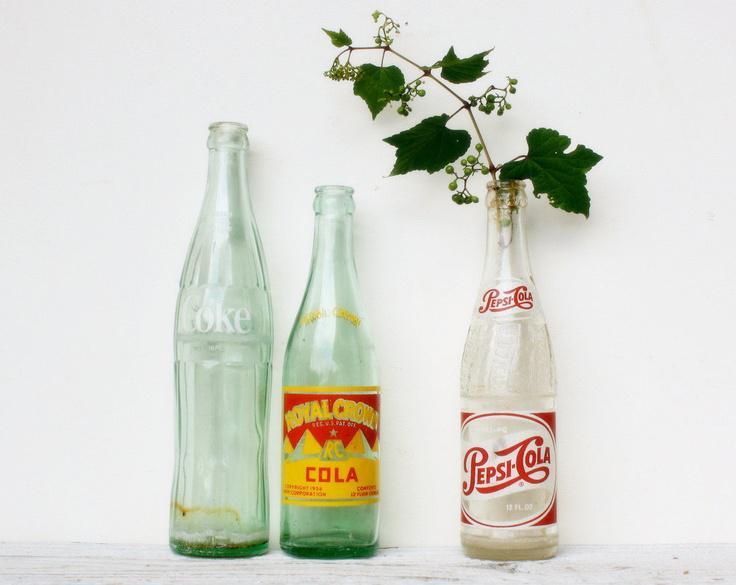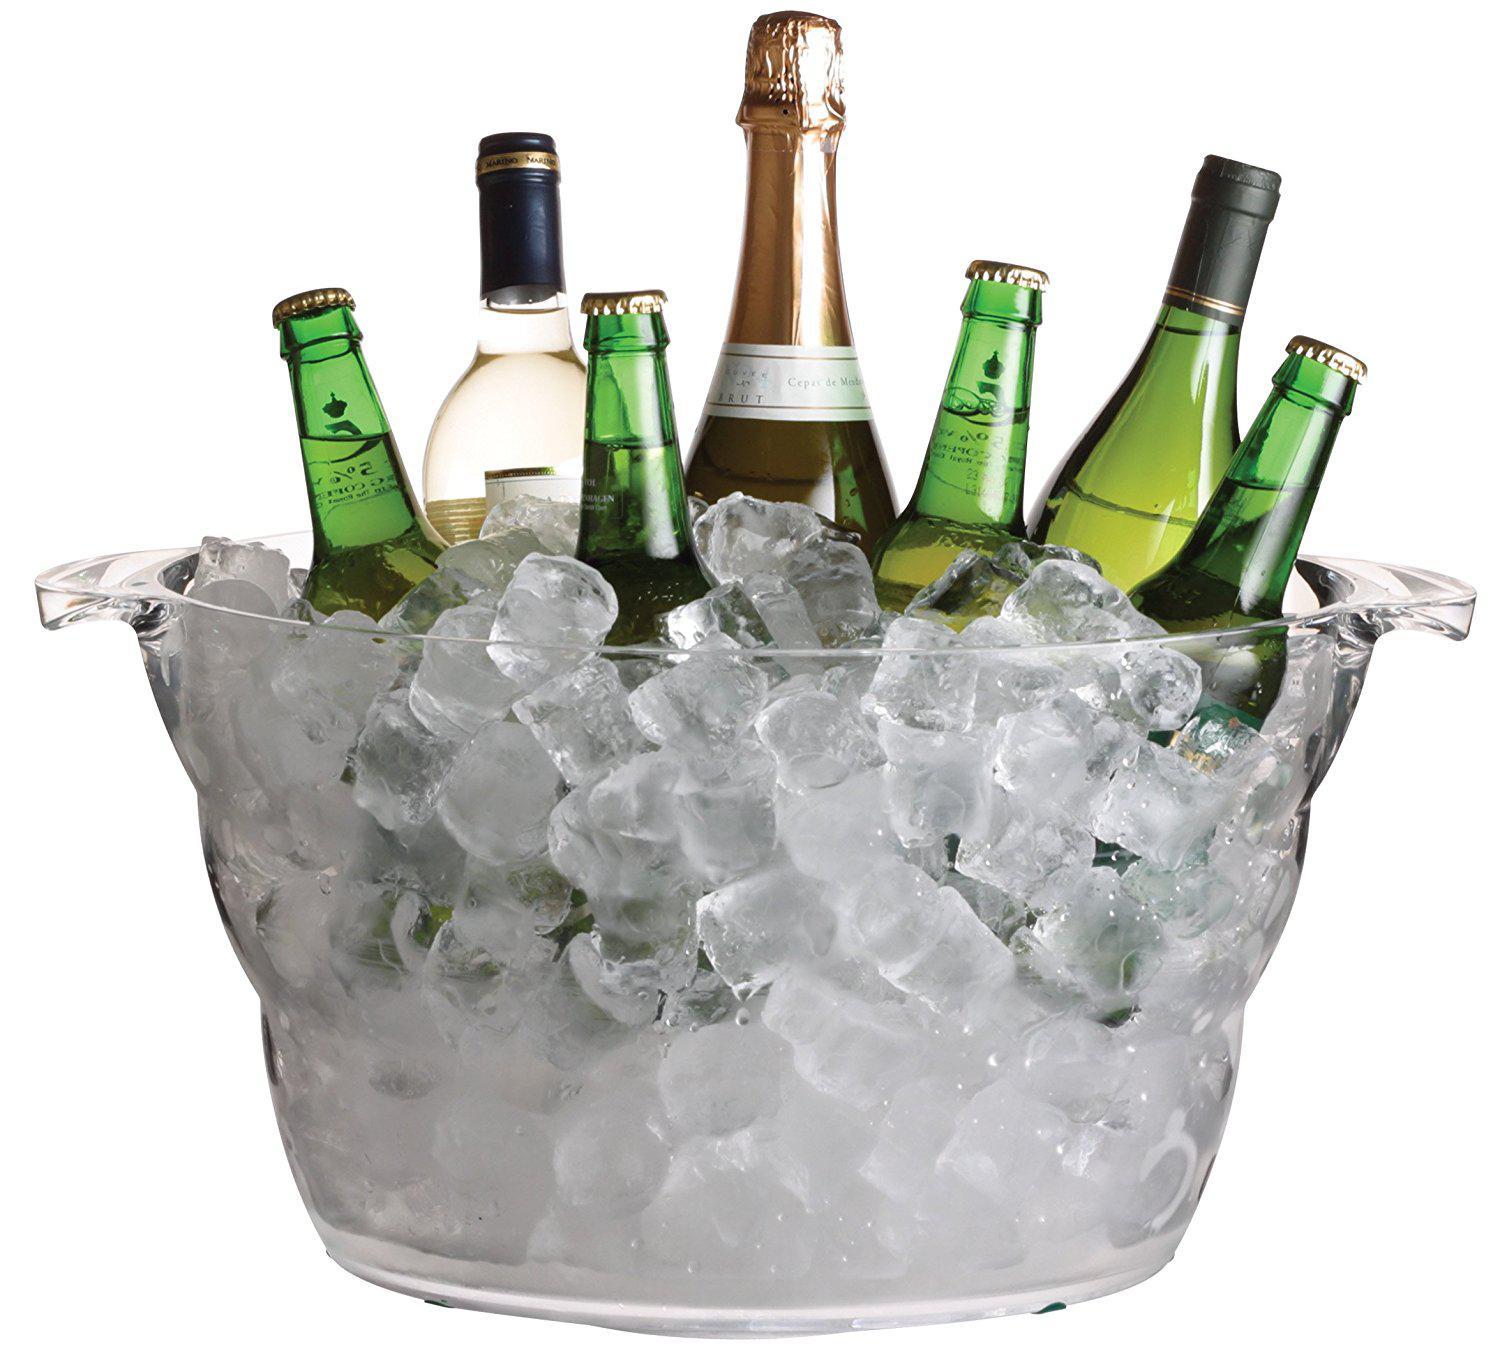The first image is the image on the left, the second image is the image on the right. For the images shown, is this caption "One image shows several bottles sticking out of a bucket." true? Answer yes or no. Yes. The first image is the image on the left, the second image is the image on the right. Analyze the images presented: Is the assertion "there are exactly three bottles in the image on the right." valid? Answer yes or no. No. 